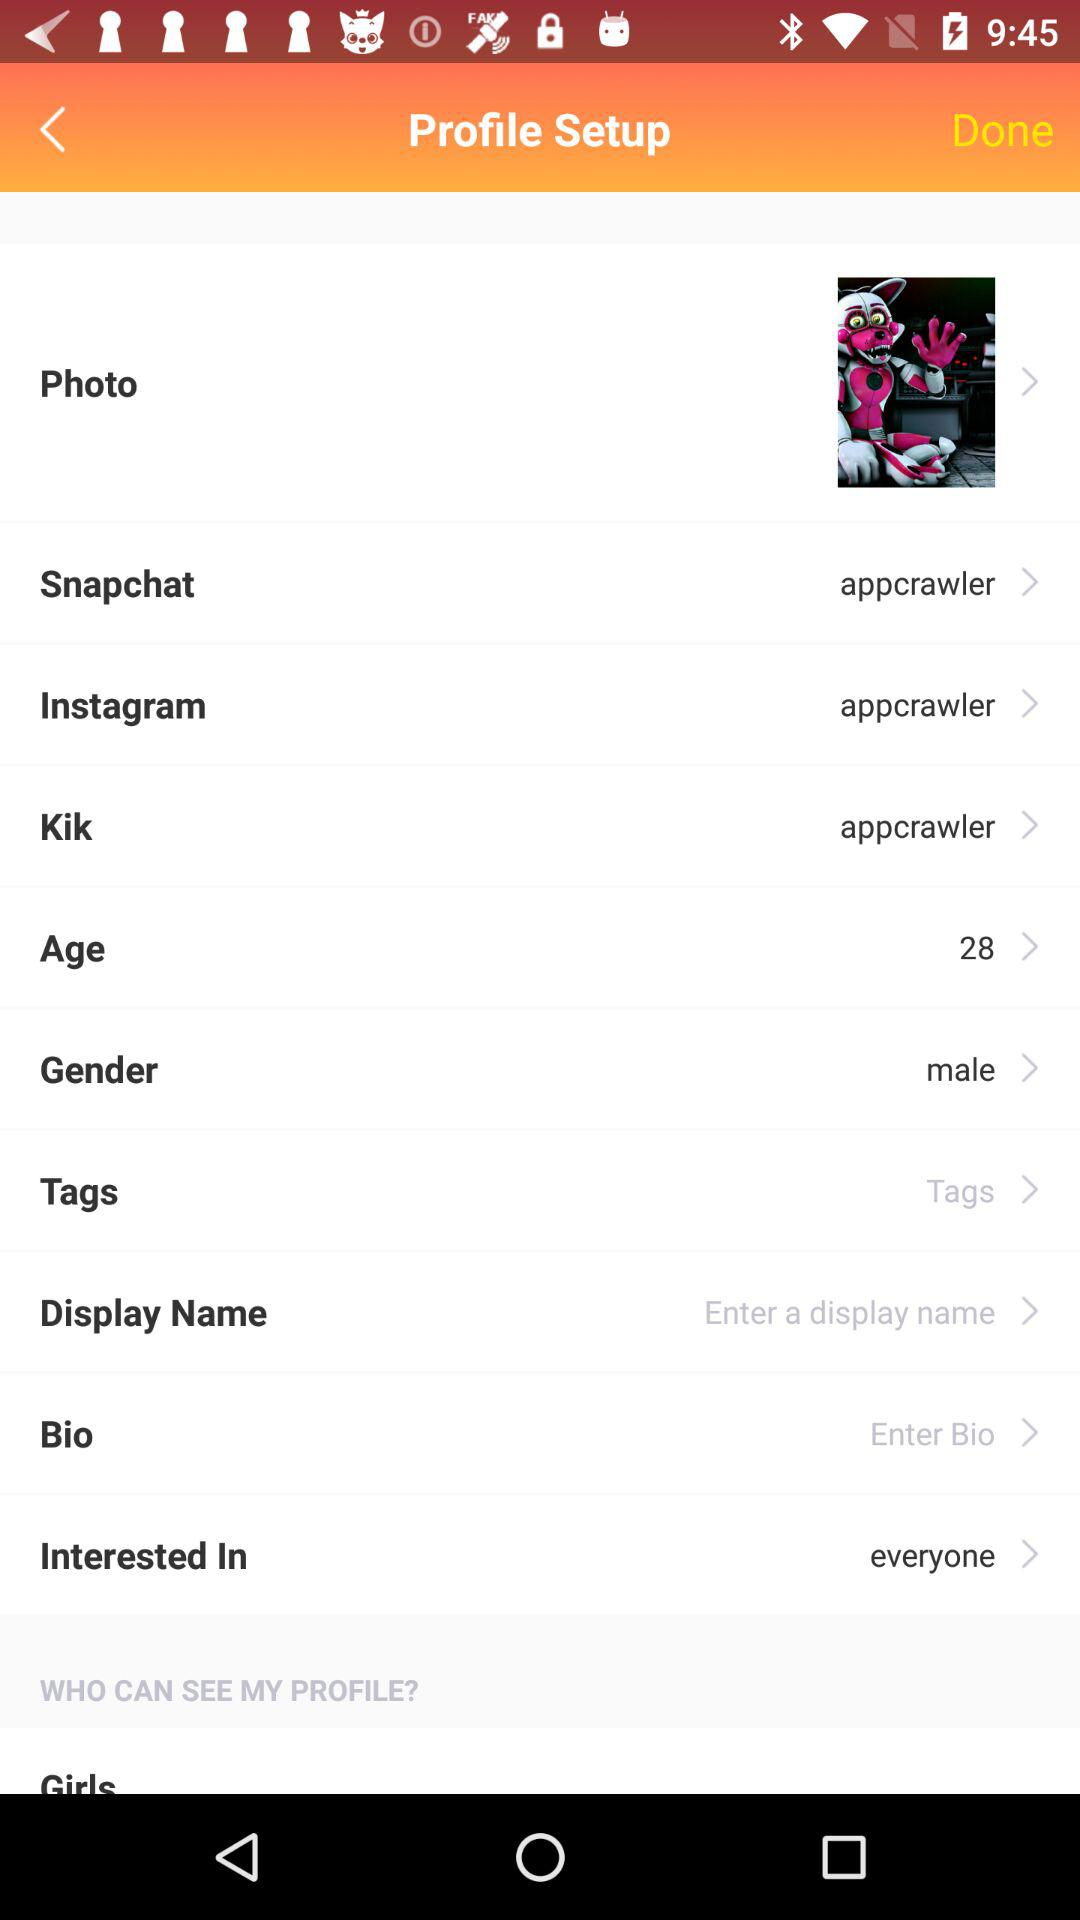What is the age? The age is 28 years old. 